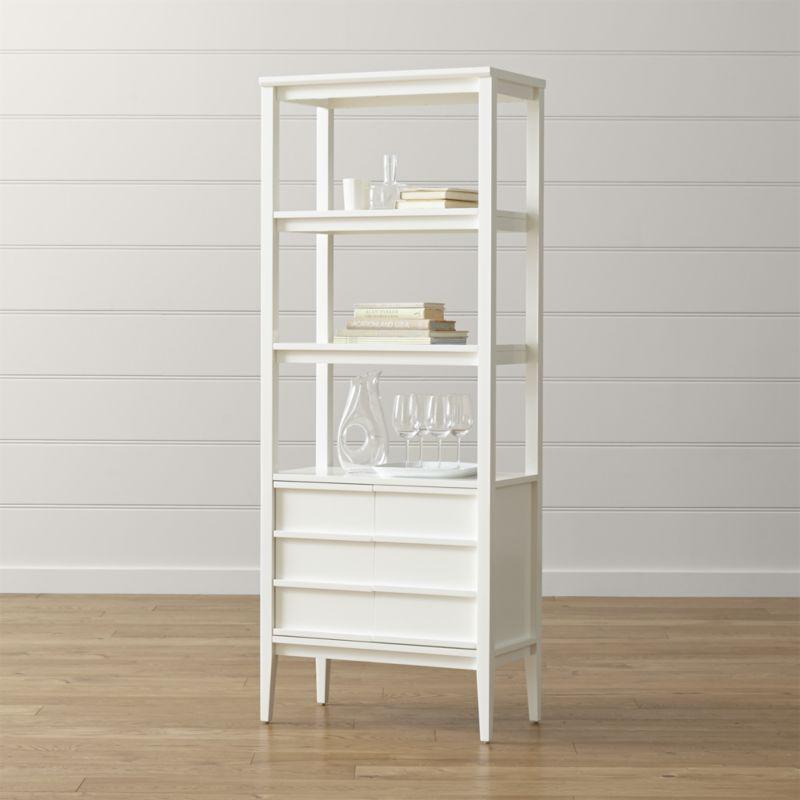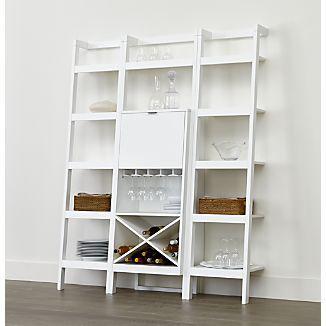The first image is the image on the left, the second image is the image on the right. Considering the images on both sides, is "The shelf unit in the left image can stand on its own." valid? Answer yes or no. Yes. The first image is the image on the left, the second image is the image on the right. For the images displayed, is the sentence "The right image features a white bookcase with three vertical rows of shelves, which is backless and leans against a wall." factually correct? Answer yes or no. Yes. 